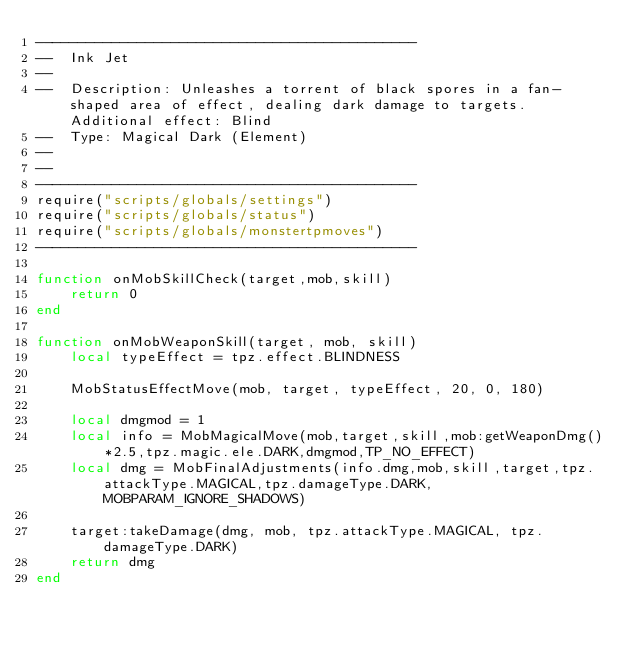<code> <loc_0><loc_0><loc_500><loc_500><_Lua_>---------------------------------------------
--  Ink Jet
--
--  Description: Unleashes a torrent of black spores in a fan-shaped area of effect, dealing dark damage to targets. Additional effect: Blind
--  Type: Magical Dark (Element)
--
--
---------------------------------------------
require("scripts/globals/settings")
require("scripts/globals/status")
require("scripts/globals/monstertpmoves")
---------------------------------------------

function onMobSkillCheck(target,mob,skill)
    return 0
end

function onMobWeaponSkill(target, mob, skill)
    local typeEffect = tpz.effect.BLINDNESS

    MobStatusEffectMove(mob, target, typeEffect, 20, 0, 180)

    local dmgmod = 1
    local info = MobMagicalMove(mob,target,skill,mob:getWeaponDmg()*2.5,tpz.magic.ele.DARK,dmgmod,TP_NO_EFFECT)
    local dmg = MobFinalAdjustments(info.dmg,mob,skill,target,tpz.attackType.MAGICAL,tpz.damageType.DARK,MOBPARAM_IGNORE_SHADOWS)

    target:takeDamage(dmg, mob, tpz.attackType.MAGICAL, tpz.damageType.DARK)
    return dmg
end
</code> 